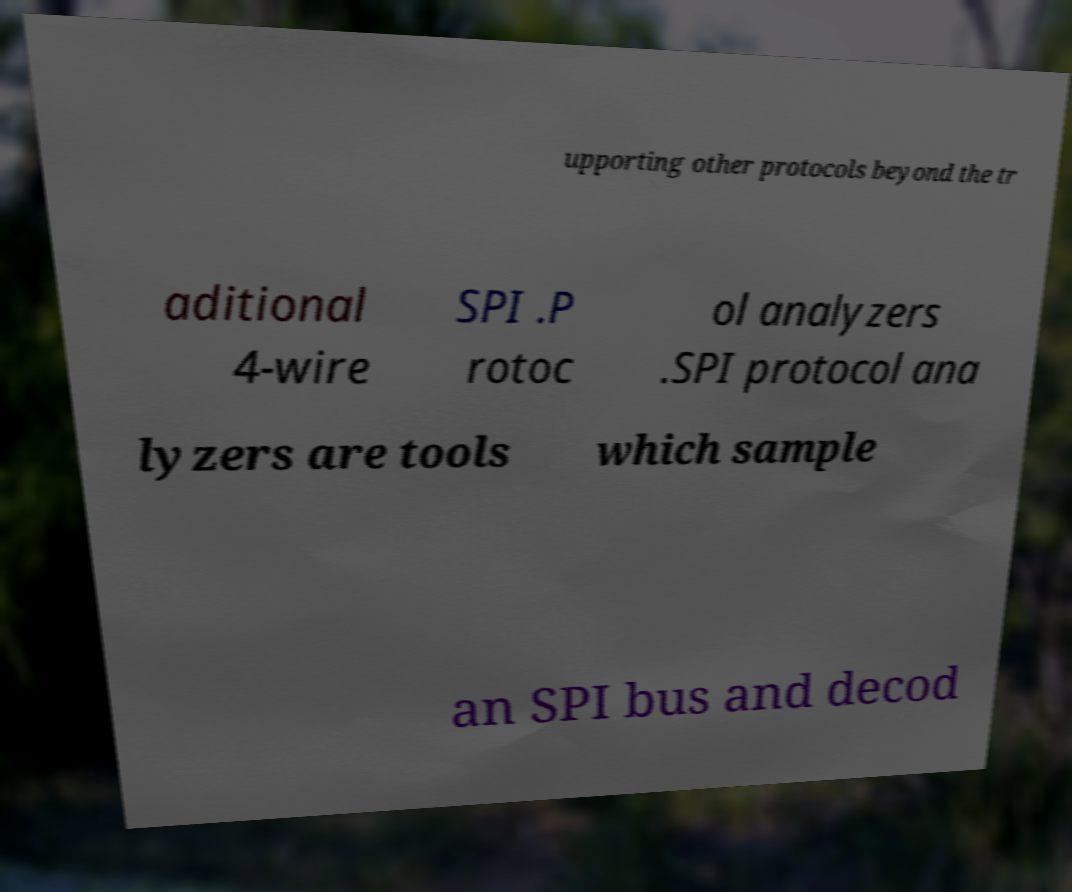Could you assist in decoding the text presented in this image and type it out clearly? upporting other protocols beyond the tr aditional 4-wire SPI .P rotoc ol analyzers .SPI protocol ana lyzers are tools which sample an SPI bus and decod 